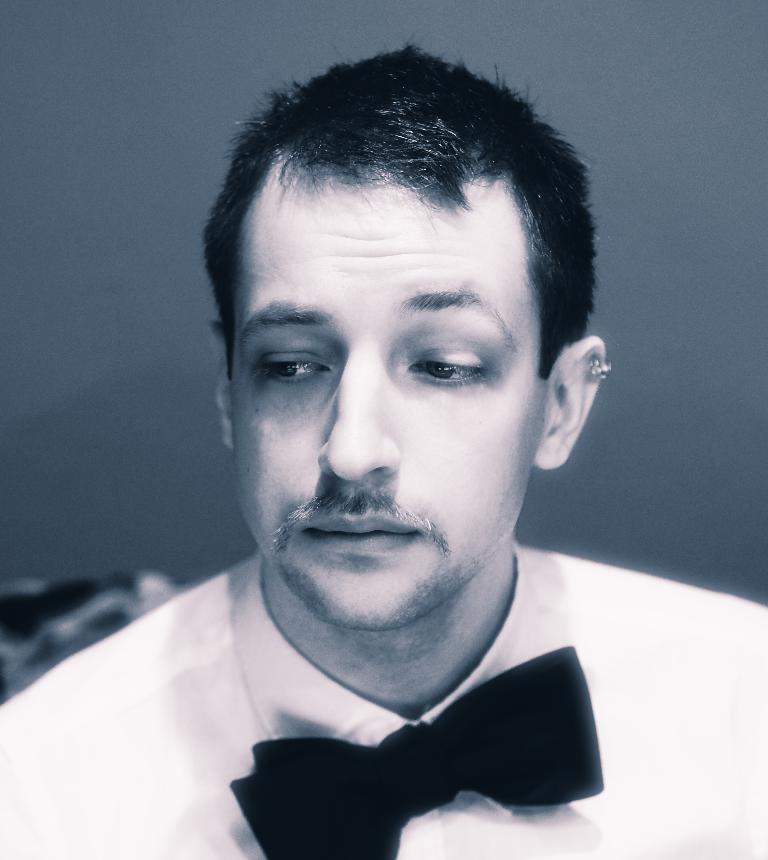In one or two sentences, can you explain what this image depicts? In this image we can see a black and white picture of a person. 